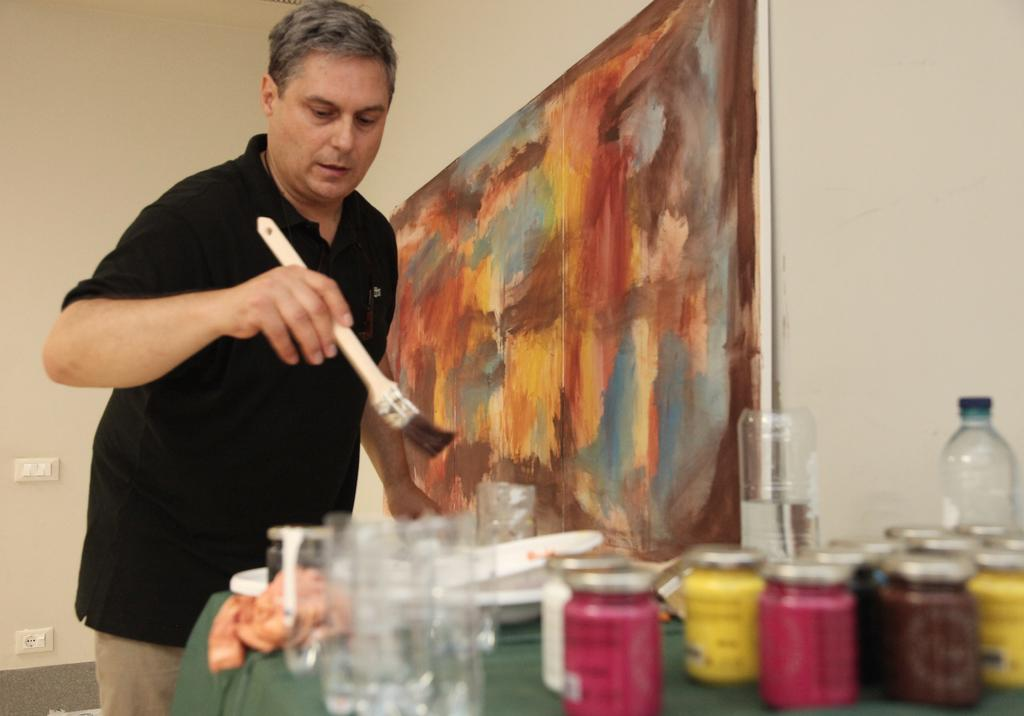What is the person in the image doing? The person is standing and holding a brush in the image. What objects can be seen near the person? There is a glass, colored jars, a bowl, and bottles in the image. Where are these objects located? These objects are on the table in the image. What can be seen on the wall in the background? There is a painting on the wall in the image. Is there a slave depicted in the painting on the wall? There is no mention of a painting depicting a slave in the provided facts, and we cannot make assumptions about the painting's content. 